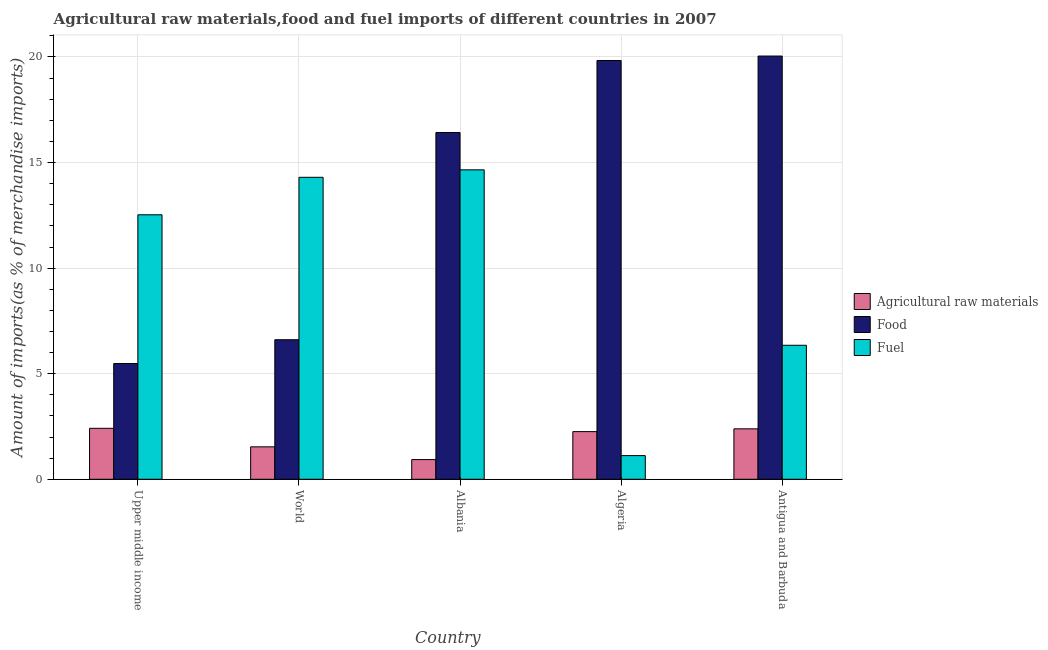What is the label of the 2nd group of bars from the left?
Offer a very short reply. World. In how many cases, is the number of bars for a given country not equal to the number of legend labels?
Make the answer very short. 0. What is the percentage of fuel imports in Antigua and Barbuda?
Make the answer very short. 6.35. Across all countries, what is the maximum percentage of food imports?
Your answer should be compact. 20.04. Across all countries, what is the minimum percentage of fuel imports?
Your answer should be very brief. 1.12. In which country was the percentage of food imports maximum?
Give a very brief answer. Antigua and Barbuda. In which country was the percentage of food imports minimum?
Ensure brevity in your answer.  Upper middle income. What is the total percentage of fuel imports in the graph?
Offer a terse response. 48.95. What is the difference between the percentage of fuel imports in Albania and that in Upper middle income?
Provide a short and direct response. 2.13. What is the difference between the percentage of raw materials imports in Antigua and Barbuda and the percentage of fuel imports in Algeria?
Ensure brevity in your answer.  1.27. What is the average percentage of raw materials imports per country?
Make the answer very short. 1.91. What is the difference between the percentage of food imports and percentage of fuel imports in Upper middle income?
Make the answer very short. -7.04. What is the ratio of the percentage of raw materials imports in Algeria to that in Antigua and Barbuda?
Keep it short and to the point. 0.94. Is the percentage of fuel imports in Upper middle income less than that in World?
Your response must be concise. Yes. What is the difference between the highest and the second highest percentage of food imports?
Give a very brief answer. 0.21. What is the difference between the highest and the lowest percentage of food imports?
Your answer should be compact. 14.56. In how many countries, is the percentage of raw materials imports greater than the average percentage of raw materials imports taken over all countries?
Your answer should be compact. 3. Is the sum of the percentage of fuel imports in Albania and Algeria greater than the maximum percentage of raw materials imports across all countries?
Provide a short and direct response. Yes. What does the 2nd bar from the left in Albania represents?
Provide a short and direct response. Food. What does the 2nd bar from the right in Algeria represents?
Make the answer very short. Food. Is it the case that in every country, the sum of the percentage of raw materials imports and percentage of food imports is greater than the percentage of fuel imports?
Provide a short and direct response. No. How many countries are there in the graph?
Your response must be concise. 5. Does the graph contain grids?
Keep it short and to the point. Yes. Where does the legend appear in the graph?
Your answer should be very brief. Center right. What is the title of the graph?
Provide a short and direct response. Agricultural raw materials,food and fuel imports of different countries in 2007. Does "Grants" appear as one of the legend labels in the graph?
Give a very brief answer. No. What is the label or title of the Y-axis?
Provide a succinct answer. Amount of imports(as % of merchandise imports). What is the Amount of imports(as % of merchandise imports) in Agricultural raw materials in Upper middle income?
Provide a succinct answer. 2.41. What is the Amount of imports(as % of merchandise imports) of Food in Upper middle income?
Make the answer very short. 5.48. What is the Amount of imports(as % of merchandise imports) of Fuel in Upper middle income?
Your answer should be compact. 12.53. What is the Amount of imports(as % of merchandise imports) of Agricultural raw materials in World?
Ensure brevity in your answer.  1.54. What is the Amount of imports(as % of merchandise imports) of Food in World?
Your answer should be compact. 6.61. What is the Amount of imports(as % of merchandise imports) of Fuel in World?
Your answer should be compact. 14.3. What is the Amount of imports(as % of merchandise imports) of Agricultural raw materials in Albania?
Your response must be concise. 0.93. What is the Amount of imports(as % of merchandise imports) of Food in Albania?
Your answer should be very brief. 16.42. What is the Amount of imports(as % of merchandise imports) of Fuel in Albania?
Provide a succinct answer. 14.66. What is the Amount of imports(as % of merchandise imports) in Agricultural raw materials in Algeria?
Provide a succinct answer. 2.26. What is the Amount of imports(as % of merchandise imports) in Food in Algeria?
Make the answer very short. 19.83. What is the Amount of imports(as % of merchandise imports) in Fuel in Algeria?
Provide a short and direct response. 1.12. What is the Amount of imports(as % of merchandise imports) in Agricultural raw materials in Antigua and Barbuda?
Keep it short and to the point. 2.39. What is the Amount of imports(as % of merchandise imports) of Food in Antigua and Barbuda?
Give a very brief answer. 20.04. What is the Amount of imports(as % of merchandise imports) of Fuel in Antigua and Barbuda?
Your answer should be compact. 6.35. Across all countries, what is the maximum Amount of imports(as % of merchandise imports) in Agricultural raw materials?
Your answer should be compact. 2.41. Across all countries, what is the maximum Amount of imports(as % of merchandise imports) of Food?
Your response must be concise. 20.04. Across all countries, what is the maximum Amount of imports(as % of merchandise imports) in Fuel?
Keep it short and to the point. 14.66. Across all countries, what is the minimum Amount of imports(as % of merchandise imports) in Agricultural raw materials?
Ensure brevity in your answer.  0.93. Across all countries, what is the minimum Amount of imports(as % of merchandise imports) of Food?
Your response must be concise. 5.48. Across all countries, what is the minimum Amount of imports(as % of merchandise imports) in Fuel?
Give a very brief answer. 1.12. What is the total Amount of imports(as % of merchandise imports) of Agricultural raw materials in the graph?
Offer a very short reply. 9.53. What is the total Amount of imports(as % of merchandise imports) in Food in the graph?
Provide a short and direct response. 68.39. What is the total Amount of imports(as % of merchandise imports) in Fuel in the graph?
Make the answer very short. 48.95. What is the difference between the Amount of imports(as % of merchandise imports) in Agricultural raw materials in Upper middle income and that in World?
Ensure brevity in your answer.  0.88. What is the difference between the Amount of imports(as % of merchandise imports) of Food in Upper middle income and that in World?
Offer a very short reply. -1.13. What is the difference between the Amount of imports(as % of merchandise imports) in Fuel in Upper middle income and that in World?
Offer a very short reply. -1.78. What is the difference between the Amount of imports(as % of merchandise imports) of Agricultural raw materials in Upper middle income and that in Albania?
Your answer should be very brief. 1.48. What is the difference between the Amount of imports(as % of merchandise imports) of Food in Upper middle income and that in Albania?
Make the answer very short. -10.94. What is the difference between the Amount of imports(as % of merchandise imports) in Fuel in Upper middle income and that in Albania?
Keep it short and to the point. -2.13. What is the difference between the Amount of imports(as % of merchandise imports) in Agricultural raw materials in Upper middle income and that in Algeria?
Keep it short and to the point. 0.16. What is the difference between the Amount of imports(as % of merchandise imports) in Food in Upper middle income and that in Algeria?
Offer a terse response. -14.35. What is the difference between the Amount of imports(as % of merchandise imports) of Fuel in Upper middle income and that in Algeria?
Make the answer very short. 11.4. What is the difference between the Amount of imports(as % of merchandise imports) of Agricultural raw materials in Upper middle income and that in Antigua and Barbuda?
Offer a terse response. 0.02. What is the difference between the Amount of imports(as % of merchandise imports) of Food in Upper middle income and that in Antigua and Barbuda?
Give a very brief answer. -14.56. What is the difference between the Amount of imports(as % of merchandise imports) in Fuel in Upper middle income and that in Antigua and Barbuda?
Provide a succinct answer. 6.18. What is the difference between the Amount of imports(as % of merchandise imports) of Agricultural raw materials in World and that in Albania?
Provide a succinct answer. 0.6. What is the difference between the Amount of imports(as % of merchandise imports) of Food in World and that in Albania?
Offer a very short reply. -9.81. What is the difference between the Amount of imports(as % of merchandise imports) in Fuel in World and that in Albania?
Keep it short and to the point. -0.35. What is the difference between the Amount of imports(as % of merchandise imports) in Agricultural raw materials in World and that in Algeria?
Your answer should be very brief. -0.72. What is the difference between the Amount of imports(as % of merchandise imports) of Food in World and that in Algeria?
Provide a succinct answer. -13.22. What is the difference between the Amount of imports(as % of merchandise imports) of Fuel in World and that in Algeria?
Your answer should be very brief. 13.18. What is the difference between the Amount of imports(as % of merchandise imports) of Agricultural raw materials in World and that in Antigua and Barbuda?
Offer a very short reply. -0.85. What is the difference between the Amount of imports(as % of merchandise imports) in Food in World and that in Antigua and Barbuda?
Your response must be concise. -13.44. What is the difference between the Amount of imports(as % of merchandise imports) in Fuel in World and that in Antigua and Barbuda?
Ensure brevity in your answer.  7.96. What is the difference between the Amount of imports(as % of merchandise imports) of Agricultural raw materials in Albania and that in Algeria?
Your answer should be very brief. -1.32. What is the difference between the Amount of imports(as % of merchandise imports) of Food in Albania and that in Algeria?
Provide a succinct answer. -3.41. What is the difference between the Amount of imports(as % of merchandise imports) in Fuel in Albania and that in Algeria?
Keep it short and to the point. 13.53. What is the difference between the Amount of imports(as % of merchandise imports) of Agricultural raw materials in Albania and that in Antigua and Barbuda?
Provide a short and direct response. -1.46. What is the difference between the Amount of imports(as % of merchandise imports) in Food in Albania and that in Antigua and Barbuda?
Keep it short and to the point. -3.62. What is the difference between the Amount of imports(as % of merchandise imports) of Fuel in Albania and that in Antigua and Barbuda?
Make the answer very short. 8.31. What is the difference between the Amount of imports(as % of merchandise imports) in Agricultural raw materials in Algeria and that in Antigua and Barbuda?
Ensure brevity in your answer.  -0.13. What is the difference between the Amount of imports(as % of merchandise imports) in Food in Algeria and that in Antigua and Barbuda?
Offer a terse response. -0.21. What is the difference between the Amount of imports(as % of merchandise imports) in Fuel in Algeria and that in Antigua and Barbuda?
Give a very brief answer. -5.22. What is the difference between the Amount of imports(as % of merchandise imports) of Agricultural raw materials in Upper middle income and the Amount of imports(as % of merchandise imports) of Food in World?
Your answer should be very brief. -4.2. What is the difference between the Amount of imports(as % of merchandise imports) in Agricultural raw materials in Upper middle income and the Amount of imports(as % of merchandise imports) in Fuel in World?
Your response must be concise. -11.89. What is the difference between the Amount of imports(as % of merchandise imports) in Food in Upper middle income and the Amount of imports(as % of merchandise imports) in Fuel in World?
Your answer should be compact. -8.82. What is the difference between the Amount of imports(as % of merchandise imports) in Agricultural raw materials in Upper middle income and the Amount of imports(as % of merchandise imports) in Food in Albania?
Your answer should be compact. -14.01. What is the difference between the Amount of imports(as % of merchandise imports) of Agricultural raw materials in Upper middle income and the Amount of imports(as % of merchandise imports) of Fuel in Albania?
Your answer should be compact. -12.24. What is the difference between the Amount of imports(as % of merchandise imports) of Food in Upper middle income and the Amount of imports(as % of merchandise imports) of Fuel in Albania?
Provide a succinct answer. -9.17. What is the difference between the Amount of imports(as % of merchandise imports) in Agricultural raw materials in Upper middle income and the Amount of imports(as % of merchandise imports) in Food in Algeria?
Offer a terse response. -17.42. What is the difference between the Amount of imports(as % of merchandise imports) in Agricultural raw materials in Upper middle income and the Amount of imports(as % of merchandise imports) in Fuel in Algeria?
Provide a short and direct response. 1.29. What is the difference between the Amount of imports(as % of merchandise imports) in Food in Upper middle income and the Amount of imports(as % of merchandise imports) in Fuel in Algeria?
Provide a succinct answer. 4.36. What is the difference between the Amount of imports(as % of merchandise imports) in Agricultural raw materials in Upper middle income and the Amount of imports(as % of merchandise imports) in Food in Antigua and Barbuda?
Your answer should be compact. -17.63. What is the difference between the Amount of imports(as % of merchandise imports) in Agricultural raw materials in Upper middle income and the Amount of imports(as % of merchandise imports) in Fuel in Antigua and Barbuda?
Make the answer very short. -3.93. What is the difference between the Amount of imports(as % of merchandise imports) of Food in Upper middle income and the Amount of imports(as % of merchandise imports) of Fuel in Antigua and Barbuda?
Give a very brief answer. -0.86. What is the difference between the Amount of imports(as % of merchandise imports) of Agricultural raw materials in World and the Amount of imports(as % of merchandise imports) of Food in Albania?
Provide a succinct answer. -14.88. What is the difference between the Amount of imports(as % of merchandise imports) in Agricultural raw materials in World and the Amount of imports(as % of merchandise imports) in Fuel in Albania?
Give a very brief answer. -13.12. What is the difference between the Amount of imports(as % of merchandise imports) of Food in World and the Amount of imports(as % of merchandise imports) of Fuel in Albania?
Ensure brevity in your answer.  -8.05. What is the difference between the Amount of imports(as % of merchandise imports) of Agricultural raw materials in World and the Amount of imports(as % of merchandise imports) of Food in Algeria?
Ensure brevity in your answer.  -18.3. What is the difference between the Amount of imports(as % of merchandise imports) in Agricultural raw materials in World and the Amount of imports(as % of merchandise imports) in Fuel in Algeria?
Your response must be concise. 0.42. What is the difference between the Amount of imports(as % of merchandise imports) in Food in World and the Amount of imports(as % of merchandise imports) in Fuel in Algeria?
Give a very brief answer. 5.49. What is the difference between the Amount of imports(as % of merchandise imports) in Agricultural raw materials in World and the Amount of imports(as % of merchandise imports) in Food in Antigua and Barbuda?
Offer a very short reply. -18.51. What is the difference between the Amount of imports(as % of merchandise imports) in Agricultural raw materials in World and the Amount of imports(as % of merchandise imports) in Fuel in Antigua and Barbuda?
Offer a very short reply. -4.81. What is the difference between the Amount of imports(as % of merchandise imports) in Food in World and the Amount of imports(as % of merchandise imports) in Fuel in Antigua and Barbuda?
Your answer should be compact. 0.26. What is the difference between the Amount of imports(as % of merchandise imports) of Agricultural raw materials in Albania and the Amount of imports(as % of merchandise imports) of Food in Algeria?
Offer a terse response. -18.9. What is the difference between the Amount of imports(as % of merchandise imports) of Agricultural raw materials in Albania and the Amount of imports(as % of merchandise imports) of Fuel in Algeria?
Provide a short and direct response. -0.19. What is the difference between the Amount of imports(as % of merchandise imports) in Food in Albania and the Amount of imports(as % of merchandise imports) in Fuel in Algeria?
Provide a succinct answer. 15.3. What is the difference between the Amount of imports(as % of merchandise imports) of Agricultural raw materials in Albania and the Amount of imports(as % of merchandise imports) of Food in Antigua and Barbuda?
Provide a succinct answer. -19.11. What is the difference between the Amount of imports(as % of merchandise imports) of Agricultural raw materials in Albania and the Amount of imports(as % of merchandise imports) of Fuel in Antigua and Barbuda?
Your answer should be compact. -5.41. What is the difference between the Amount of imports(as % of merchandise imports) of Food in Albania and the Amount of imports(as % of merchandise imports) of Fuel in Antigua and Barbuda?
Offer a very short reply. 10.08. What is the difference between the Amount of imports(as % of merchandise imports) in Agricultural raw materials in Algeria and the Amount of imports(as % of merchandise imports) in Food in Antigua and Barbuda?
Offer a terse response. -17.79. What is the difference between the Amount of imports(as % of merchandise imports) in Agricultural raw materials in Algeria and the Amount of imports(as % of merchandise imports) in Fuel in Antigua and Barbuda?
Offer a terse response. -4.09. What is the difference between the Amount of imports(as % of merchandise imports) of Food in Algeria and the Amount of imports(as % of merchandise imports) of Fuel in Antigua and Barbuda?
Provide a short and direct response. 13.49. What is the average Amount of imports(as % of merchandise imports) of Agricultural raw materials per country?
Your response must be concise. 1.91. What is the average Amount of imports(as % of merchandise imports) in Food per country?
Your response must be concise. 13.68. What is the average Amount of imports(as % of merchandise imports) in Fuel per country?
Keep it short and to the point. 9.79. What is the difference between the Amount of imports(as % of merchandise imports) of Agricultural raw materials and Amount of imports(as % of merchandise imports) of Food in Upper middle income?
Your answer should be compact. -3.07. What is the difference between the Amount of imports(as % of merchandise imports) of Agricultural raw materials and Amount of imports(as % of merchandise imports) of Fuel in Upper middle income?
Your response must be concise. -10.11. What is the difference between the Amount of imports(as % of merchandise imports) of Food and Amount of imports(as % of merchandise imports) of Fuel in Upper middle income?
Give a very brief answer. -7.04. What is the difference between the Amount of imports(as % of merchandise imports) of Agricultural raw materials and Amount of imports(as % of merchandise imports) of Food in World?
Your response must be concise. -5.07. What is the difference between the Amount of imports(as % of merchandise imports) of Agricultural raw materials and Amount of imports(as % of merchandise imports) of Fuel in World?
Ensure brevity in your answer.  -12.76. What is the difference between the Amount of imports(as % of merchandise imports) of Food and Amount of imports(as % of merchandise imports) of Fuel in World?
Give a very brief answer. -7.69. What is the difference between the Amount of imports(as % of merchandise imports) of Agricultural raw materials and Amount of imports(as % of merchandise imports) of Food in Albania?
Your answer should be compact. -15.49. What is the difference between the Amount of imports(as % of merchandise imports) in Agricultural raw materials and Amount of imports(as % of merchandise imports) in Fuel in Albania?
Offer a very short reply. -13.72. What is the difference between the Amount of imports(as % of merchandise imports) in Food and Amount of imports(as % of merchandise imports) in Fuel in Albania?
Ensure brevity in your answer.  1.77. What is the difference between the Amount of imports(as % of merchandise imports) in Agricultural raw materials and Amount of imports(as % of merchandise imports) in Food in Algeria?
Offer a terse response. -17.58. What is the difference between the Amount of imports(as % of merchandise imports) of Agricultural raw materials and Amount of imports(as % of merchandise imports) of Fuel in Algeria?
Your answer should be very brief. 1.14. What is the difference between the Amount of imports(as % of merchandise imports) in Food and Amount of imports(as % of merchandise imports) in Fuel in Algeria?
Offer a terse response. 18.71. What is the difference between the Amount of imports(as % of merchandise imports) of Agricultural raw materials and Amount of imports(as % of merchandise imports) of Food in Antigua and Barbuda?
Your answer should be very brief. -17.66. What is the difference between the Amount of imports(as % of merchandise imports) in Agricultural raw materials and Amount of imports(as % of merchandise imports) in Fuel in Antigua and Barbuda?
Give a very brief answer. -3.96. What is the difference between the Amount of imports(as % of merchandise imports) in Food and Amount of imports(as % of merchandise imports) in Fuel in Antigua and Barbuda?
Give a very brief answer. 13.7. What is the ratio of the Amount of imports(as % of merchandise imports) of Agricultural raw materials in Upper middle income to that in World?
Keep it short and to the point. 1.57. What is the ratio of the Amount of imports(as % of merchandise imports) in Food in Upper middle income to that in World?
Offer a terse response. 0.83. What is the ratio of the Amount of imports(as % of merchandise imports) in Fuel in Upper middle income to that in World?
Make the answer very short. 0.88. What is the ratio of the Amount of imports(as % of merchandise imports) in Agricultural raw materials in Upper middle income to that in Albania?
Offer a very short reply. 2.59. What is the ratio of the Amount of imports(as % of merchandise imports) in Food in Upper middle income to that in Albania?
Your answer should be compact. 0.33. What is the ratio of the Amount of imports(as % of merchandise imports) in Fuel in Upper middle income to that in Albania?
Provide a succinct answer. 0.85. What is the ratio of the Amount of imports(as % of merchandise imports) in Agricultural raw materials in Upper middle income to that in Algeria?
Your answer should be compact. 1.07. What is the ratio of the Amount of imports(as % of merchandise imports) in Food in Upper middle income to that in Algeria?
Keep it short and to the point. 0.28. What is the ratio of the Amount of imports(as % of merchandise imports) of Fuel in Upper middle income to that in Algeria?
Make the answer very short. 11.17. What is the ratio of the Amount of imports(as % of merchandise imports) of Agricultural raw materials in Upper middle income to that in Antigua and Barbuda?
Provide a succinct answer. 1.01. What is the ratio of the Amount of imports(as % of merchandise imports) of Food in Upper middle income to that in Antigua and Barbuda?
Your response must be concise. 0.27. What is the ratio of the Amount of imports(as % of merchandise imports) of Fuel in Upper middle income to that in Antigua and Barbuda?
Keep it short and to the point. 1.97. What is the ratio of the Amount of imports(as % of merchandise imports) of Agricultural raw materials in World to that in Albania?
Offer a terse response. 1.65. What is the ratio of the Amount of imports(as % of merchandise imports) of Food in World to that in Albania?
Provide a short and direct response. 0.4. What is the ratio of the Amount of imports(as % of merchandise imports) in Fuel in World to that in Albania?
Your answer should be compact. 0.98. What is the ratio of the Amount of imports(as % of merchandise imports) in Agricultural raw materials in World to that in Algeria?
Give a very brief answer. 0.68. What is the ratio of the Amount of imports(as % of merchandise imports) in Food in World to that in Algeria?
Your response must be concise. 0.33. What is the ratio of the Amount of imports(as % of merchandise imports) in Fuel in World to that in Algeria?
Keep it short and to the point. 12.76. What is the ratio of the Amount of imports(as % of merchandise imports) in Agricultural raw materials in World to that in Antigua and Barbuda?
Offer a very short reply. 0.64. What is the ratio of the Amount of imports(as % of merchandise imports) in Food in World to that in Antigua and Barbuda?
Give a very brief answer. 0.33. What is the ratio of the Amount of imports(as % of merchandise imports) in Fuel in World to that in Antigua and Barbuda?
Offer a very short reply. 2.25. What is the ratio of the Amount of imports(as % of merchandise imports) of Agricultural raw materials in Albania to that in Algeria?
Keep it short and to the point. 0.41. What is the ratio of the Amount of imports(as % of merchandise imports) of Food in Albania to that in Algeria?
Provide a succinct answer. 0.83. What is the ratio of the Amount of imports(as % of merchandise imports) in Fuel in Albania to that in Algeria?
Your response must be concise. 13.07. What is the ratio of the Amount of imports(as % of merchandise imports) of Agricultural raw materials in Albania to that in Antigua and Barbuda?
Your response must be concise. 0.39. What is the ratio of the Amount of imports(as % of merchandise imports) in Food in Albania to that in Antigua and Barbuda?
Offer a very short reply. 0.82. What is the ratio of the Amount of imports(as % of merchandise imports) of Fuel in Albania to that in Antigua and Barbuda?
Your response must be concise. 2.31. What is the ratio of the Amount of imports(as % of merchandise imports) in Agricultural raw materials in Algeria to that in Antigua and Barbuda?
Your response must be concise. 0.94. What is the ratio of the Amount of imports(as % of merchandise imports) in Fuel in Algeria to that in Antigua and Barbuda?
Keep it short and to the point. 0.18. What is the difference between the highest and the second highest Amount of imports(as % of merchandise imports) of Agricultural raw materials?
Your answer should be very brief. 0.02. What is the difference between the highest and the second highest Amount of imports(as % of merchandise imports) of Food?
Ensure brevity in your answer.  0.21. What is the difference between the highest and the second highest Amount of imports(as % of merchandise imports) of Fuel?
Your answer should be very brief. 0.35. What is the difference between the highest and the lowest Amount of imports(as % of merchandise imports) of Agricultural raw materials?
Keep it short and to the point. 1.48. What is the difference between the highest and the lowest Amount of imports(as % of merchandise imports) of Food?
Your answer should be compact. 14.56. What is the difference between the highest and the lowest Amount of imports(as % of merchandise imports) of Fuel?
Offer a terse response. 13.53. 